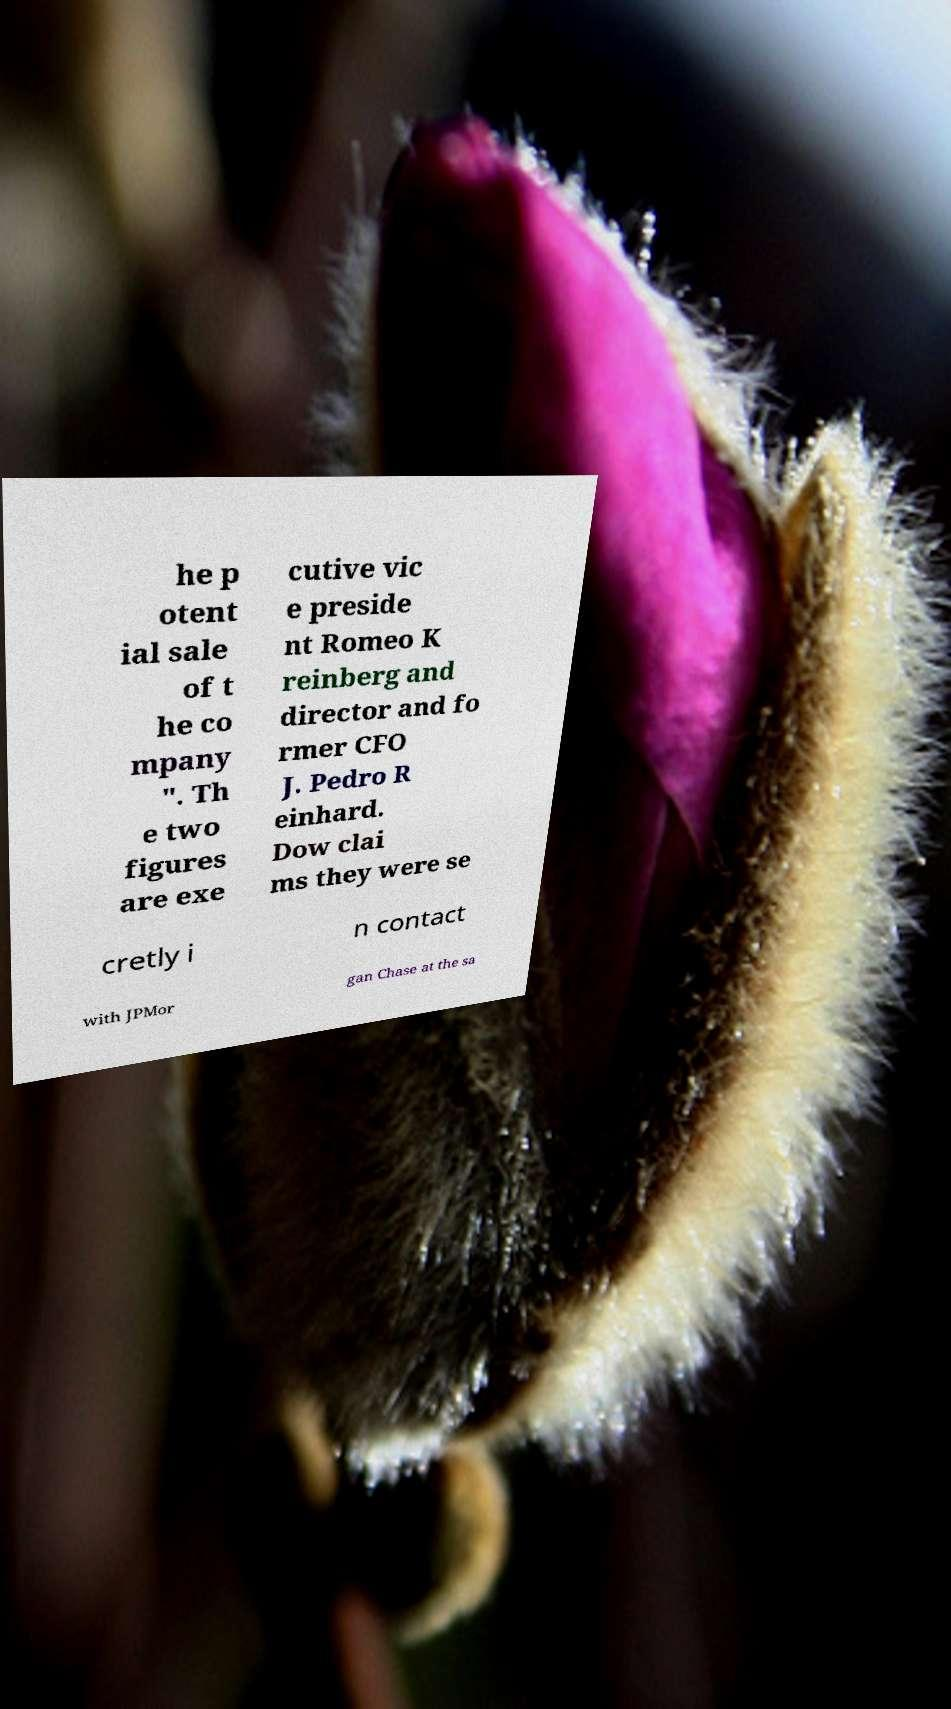Can you read and provide the text displayed in the image?This photo seems to have some interesting text. Can you extract and type it out for me? he p otent ial sale of t he co mpany ". Th e two figures are exe cutive vic e preside nt Romeo K reinberg and director and fo rmer CFO J. Pedro R einhard. Dow clai ms they were se cretly i n contact with JPMor gan Chase at the sa 